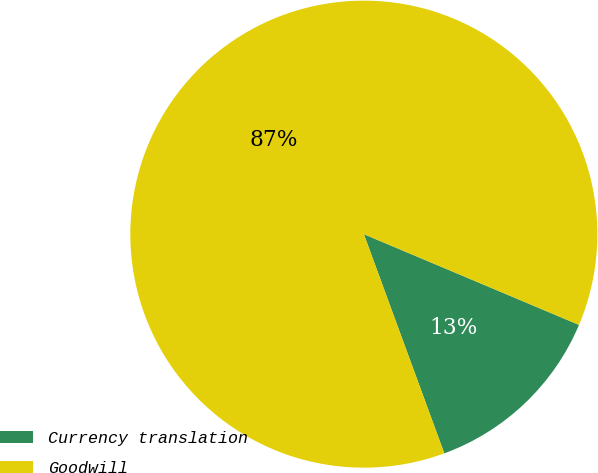Convert chart. <chart><loc_0><loc_0><loc_500><loc_500><pie_chart><fcel>Currency translation<fcel>Goodwill<nl><fcel>13.05%<fcel>86.95%<nl></chart> 